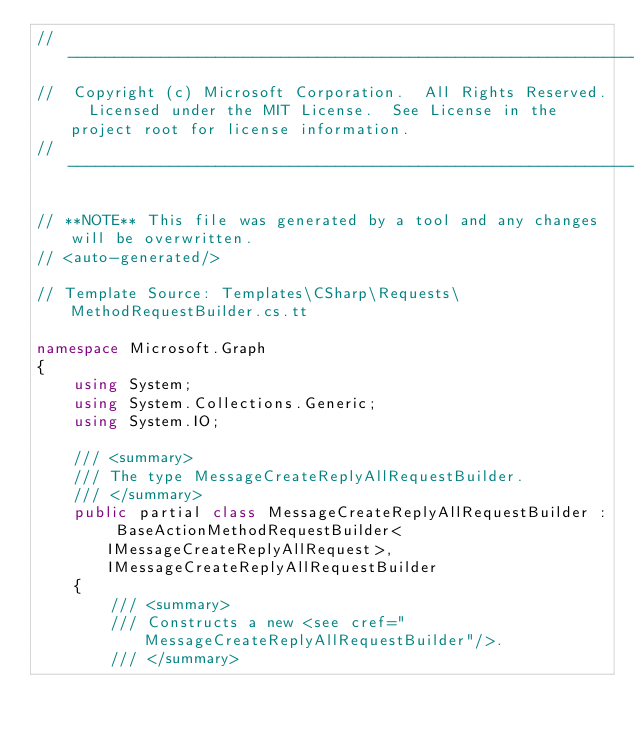Convert code to text. <code><loc_0><loc_0><loc_500><loc_500><_C#_>// ------------------------------------------------------------------------------
//  Copyright (c) Microsoft Corporation.  All Rights Reserved.  Licensed under the MIT License.  See License in the project root for license information.
// ------------------------------------------------------------------------------

// **NOTE** This file was generated by a tool and any changes will be overwritten.
// <auto-generated/>

// Template Source: Templates\CSharp\Requests\MethodRequestBuilder.cs.tt

namespace Microsoft.Graph
{
    using System;
    using System.Collections.Generic;
    using System.IO;

    /// <summary>
    /// The type MessageCreateReplyAllRequestBuilder.
    /// </summary>
    public partial class MessageCreateReplyAllRequestBuilder : BaseActionMethodRequestBuilder<IMessageCreateReplyAllRequest>, IMessageCreateReplyAllRequestBuilder
    {
        /// <summary>
        /// Constructs a new <see cref="MessageCreateReplyAllRequestBuilder"/>.
        /// </summary></code> 